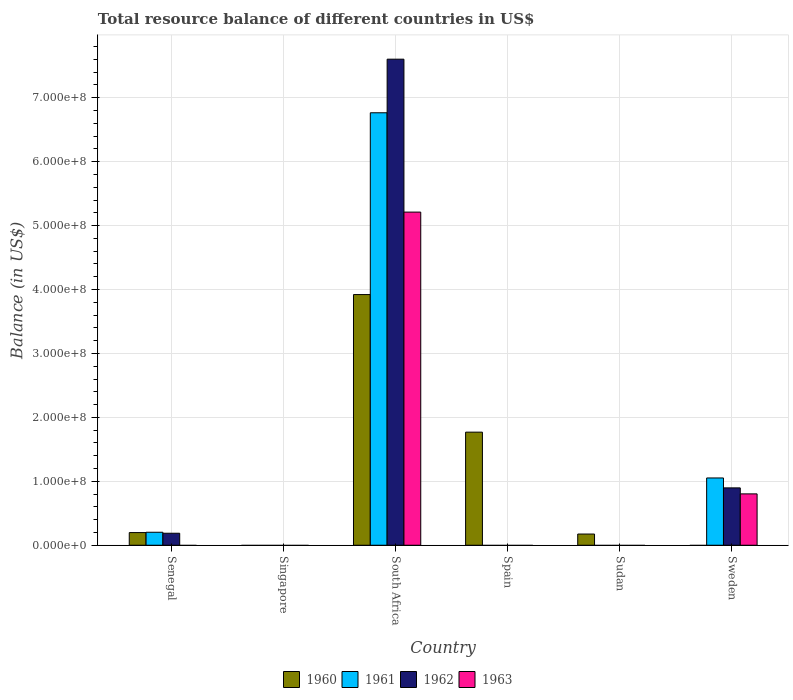Are the number of bars on each tick of the X-axis equal?
Provide a succinct answer. No. How many bars are there on the 3rd tick from the left?
Ensure brevity in your answer.  4. How many bars are there on the 5th tick from the right?
Your response must be concise. 0. What is the label of the 5th group of bars from the left?
Keep it short and to the point. Sudan. What is the total resource balance in 1960 in Spain?
Make the answer very short. 1.77e+08. Across all countries, what is the maximum total resource balance in 1963?
Make the answer very short. 5.21e+08. In which country was the total resource balance in 1963 maximum?
Provide a succinct answer. South Africa. What is the total total resource balance in 1960 in the graph?
Provide a succinct answer. 6.06e+08. What is the difference between the total resource balance in 1962 in Senegal and that in South Africa?
Your response must be concise. -7.42e+08. What is the difference between the total resource balance in 1962 in Sweden and the total resource balance in 1963 in Spain?
Offer a very short reply. 8.97e+07. What is the average total resource balance in 1963 per country?
Offer a terse response. 1.00e+08. What is the difference between the total resource balance of/in 1961 and total resource balance of/in 1963 in South Africa?
Offer a very short reply. 1.55e+08. What is the ratio of the total resource balance in 1960 in Senegal to that in Spain?
Your answer should be compact. 0.11. Is the total resource balance in 1960 in Senegal less than that in Spain?
Provide a succinct answer. Yes. What is the difference between the highest and the second highest total resource balance in 1960?
Keep it short and to the point. -3.72e+08. What is the difference between the highest and the lowest total resource balance in 1963?
Offer a terse response. 5.21e+08. In how many countries, is the total resource balance in 1962 greater than the average total resource balance in 1962 taken over all countries?
Offer a terse response. 1. Are all the bars in the graph horizontal?
Your response must be concise. No. What is the difference between two consecutive major ticks on the Y-axis?
Ensure brevity in your answer.  1.00e+08. Does the graph contain any zero values?
Keep it short and to the point. Yes. Does the graph contain grids?
Your answer should be compact. Yes. How many legend labels are there?
Your response must be concise. 4. What is the title of the graph?
Make the answer very short. Total resource balance of different countries in US$. Does "1974" appear as one of the legend labels in the graph?
Offer a very short reply. No. What is the label or title of the X-axis?
Offer a terse response. Country. What is the label or title of the Y-axis?
Provide a short and direct response. Balance (in US$). What is the Balance (in US$) of 1960 in Senegal?
Keep it short and to the point. 1.98e+07. What is the Balance (in US$) of 1961 in Senegal?
Your response must be concise. 2.03e+07. What is the Balance (in US$) of 1962 in Senegal?
Provide a short and direct response. 1.88e+07. What is the Balance (in US$) in 1963 in Senegal?
Your answer should be very brief. 0. What is the Balance (in US$) of 1962 in Singapore?
Your answer should be very brief. 0. What is the Balance (in US$) of 1960 in South Africa?
Your response must be concise. 3.92e+08. What is the Balance (in US$) in 1961 in South Africa?
Give a very brief answer. 6.77e+08. What is the Balance (in US$) in 1962 in South Africa?
Provide a succinct answer. 7.60e+08. What is the Balance (in US$) of 1963 in South Africa?
Ensure brevity in your answer.  5.21e+08. What is the Balance (in US$) in 1960 in Spain?
Offer a very short reply. 1.77e+08. What is the Balance (in US$) in 1963 in Spain?
Provide a short and direct response. 0. What is the Balance (in US$) in 1960 in Sudan?
Provide a succinct answer. 1.75e+07. What is the Balance (in US$) in 1961 in Sudan?
Your answer should be very brief. 0. What is the Balance (in US$) in 1963 in Sudan?
Provide a succinct answer. 0. What is the Balance (in US$) in 1960 in Sweden?
Make the answer very short. 0. What is the Balance (in US$) of 1961 in Sweden?
Offer a very short reply. 1.05e+08. What is the Balance (in US$) in 1962 in Sweden?
Make the answer very short. 8.97e+07. What is the Balance (in US$) of 1963 in Sweden?
Your answer should be very brief. 8.03e+07. Across all countries, what is the maximum Balance (in US$) in 1960?
Your answer should be compact. 3.92e+08. Across all countries, what is the maximum Balance (in US$) in 1961?
Provide a succinct answer. 6.77e+08. Across all countries, what is the maximum Balance (in US$) of 1962?
Your answer should be very brief. 7.60e+08. Across all countries, what is the maximum Balance (in US$) of 1963?
Keep it short and to the point. 5.21e+08. Across all countries, what is the minimum Balance (in US$) in 1960?
Make the answer very short. 0. Across all countries, what is the minimum Balance (in US$) in 1961?
Offer a terse response. 0. What is the total Balance (in US$) of 1960 in the graph?
Provide a succinct answer. 6.06e+08. What is the total Balance (in US$) of 1961 in the graph?
Provide a succinct answer. 8.02e+08. What is the total Balance (in US$) in 1962 in the graph?
Ensure brevity in your answer.  8.69e+08. What is the total Balance (in US$) in 1963 in the graph?
Make the answer very short. 6.01e+08. What is the difference between the Balance (in US$) of 1960 in Senegal and that in South Africa?
Offer a terse response. -3.72e+08. What is the difference between the Balance (in US$) of 1961 in Senegal and that in South Africa?
Your answer should be compact. -6.56e+08. What is the difference between the Balance (in US$) in 1962 in Senegal and that in South Africa?
Your answer should be very brief. -7.42e+08. What is the difference between the Balance (in US$) of 1960 in Senegal and that in Spain?
Your response must be concise. -1.57e+08. What is the difference between the Balance (in US$) in 1960 in Senegal and that in Sudan?
Provide a succinct answer. 2.27e+06. What is the difference between the Balance (in US$) in 1961 in Senegal and that in Sweden?
Make the answer very short. -8.49e+07. What is the difference between the Balance (in US$) in 1962 in Senegal and that in Sweden?
Provide a short and direct response. -7.10e+07. What is the difference between the Balance (in US$) of 1960 in South Africa and that in Spain?
Provide a succinct answer. 2.15e+08. What is the difference between the Balance (in US$) in 1960 in South Africa and that in Sudan?
Ensure brevity in your answer.  3.75e+08. What is the difference between the Balance (in US$) of 1961 in South Africa and that in Sweden?
Your answer should be compact. 5.71e+08. What is the difference between the Balance (in US$) of 1962 in South Africa and that in Sweden?
Your answer should be compact. 6.71e+08. What is the difference between the Balance (in US$) of 1963 in South Africa and that in Sweden?
Keep it short and to the point. 4.41e+08. What is the difference between the Balance (in US$) in 1960 in Spain and that in Sudan?
Ensure brevity in your answer.  1.59e+08. What is the difference between the Balance (in US$) of 1960 in Senegal and the Balance (in US$) of 1961 in South Africa?
Ensure brevity in your answer.  -6.57e+08. What is the difference between the Balance (in US$) in 1960 in Senegal and the Balance (in US$) in 1962 in South Africa?
Give a very brief answer. -7.41e+08. What is the difference between the Balance (in US$) of 1960 in Senegal and the Balance (in US$) of 1963 in South Africa?
Offer a very short reply. -5.01e+08. What is the difference between the Balance (in US$) of 1961 in Senegal and the Balance (in US$) of 1962 in South Africa?
Offer a terse response. -7.40e+08. What is the difference between the Balance (in US$) of 1961 in Senegal and the Balance (in US$) of 1963 in South Africa?
Give a very brief answer. -5.01e+08. What is the difference between the Balance (in US$) in 1962 in Senegal and the Balance (in US$) in 1963 in South Africa?
Give a very brief answer. -5.02e+08. What is the difference between the Balance (in US$) in 1960 in Senegal and the Balance (in US$) in 1961 in Sweden?
Provide a short and direct response. -8.54e+07. What is the difference between the Balance (in US$) in 1960 in Senegal and the Balance (in US$) in 1962 in Sweden?
Keep it short and to the point. -6.99e+07. What is the difference between the Balance (in US$) in 1960 in Senegal and the Balance (in US$) in 1963 in Sweden?
Offer a very short reply. -6.05e+07. What is the difference between the Balance (in US$) of 1961 in Senegal and the Balance (in US$) of 1962 in Sweden?
Make the answer very short. -6.94e+07. What is the difference between the Balance (in US$) in 1961 in Senegal and the Balance (in US$) in 1963 in Sweden?
Offer a terse response. -6.00e+07. What is the difference between the Balance (in US$) in 1962 in Senegal and the Balance (in US$) in 1963 in Sweden?
Ensure brevity in your answer.  -6.16e+07. What is the difference between the Balance (in US$) in 1960 in South Africa and the Balance (in US$) in 1961 in Sweden?
Your response must be concise. 2.87e+08. What is the difference between the Balance (in US$) of 1960 in South Africa and the Balance (in US$) of 1962 in Sweden?
Offer a very short reply. 3.02e+08. What is the difference between the Balance (in US$) of 1960 in South Africa and the Balance (in US$) of 1963 in Sweden?
Your answer should be very brief. 3.12e+08. What is the difference between the Balance (in US$) in 1961 in South Africa and the Balance (in US$) in 1962 in Sweden?
Offer a terse response. 5.87e+08. What is the difference between the Balance (in US$) in 1961 in South Africa and the Balance (in US$) in 1963 in Sweden?
Keep it short and to the point. 5.96e+08. What is the difference between the Balance (in US$) of 1962 in South Africa and the Balance (in US$) of 1963 in Sweden?
Your answer should be compact. 6.80e+08. What is the difference between the Balance (in US$) of 1960 in Spain and the Balance (in US$) of 1961 in Sweden?
Ensure brevity in your answer.  7.17e+07. What is the difference between the Balance (in US$) of 1960 in Spain and the Balance (in US$) of 1962 in Sweden?
Provide a succinct answer. 8.72e+07. What is the difference between the Balance (in US$) in 1960 in Spain and the Balance (in US$) in 1963 in Sweden?
Make the answer very short. 9.66e+07. What is the difference between the Balance (in US$) in 1960 in Sudan and the Balance (in US$) in 1961 in Sweden?
Offer a very short reply. -8.77e+07. What is the difference between the Balance (in US$) of 1960 in Sudan and the Balance (in US$) of 1962 in Sweden?
Your answer should be compact. -7.22e+07. What is the difference between the Balance (in US$) of 1960 in Sudan and the Balance (in US$) of 1963 in Sweden?
Offer a terse response. -6.28e+07. What is the average Balance (in US$) in 1960 per country?
Offer a very short reply. 1.01e+08. What is the average Balance (in US$) in 1961 per country?
Your answer should be very brief. 1.34e+08. What is the average Balance (in US$) in 1962 per country?
Give a very brief answer. 1.45e+08. What is the average Balance (in US$) in 1963 per country?
Offer a very short reply. 1.00e+08. What is the difference between the Balance (in US$) of 1960 and Balance (in US$) of 1961 in Senegal?
Give a very brief answer. -5.23e+05. What is the difference between the Balance (in US$) in 1960 and Balance (in US$) in 1962 in Senegal?
Ensure brevity in your answer.  1.03e+06. What is the difference between the Balance (in US$) of 1961 and Balance (in US$) of 1962 in Senegal?
Provide a succinct answer. 1.55e+06. What is the difference between the Balance (in US$) in 1960 and Balance (in US$) in 1961 in South Africa?
Give a very brief answer. -2.84e+08. What is the difference between the Balance (in US$) in 1960 and Balance (in US$) in 1962 in South Africa?
Provide a short and direct response. -3.68e+08. What is the difference between the Balance (in US$) of 1960 and Balance (in US$) of 1963 in South Africa?
Keep it short and to the point. -1.29e+08. What is the difference between the Balance (in US$) in 1961 and Balance (in US$) in 1962 in South Africa?
Offer a terse response. -8.38e+07. What is the difference between the Balance (in US$) of 1961 and Balance (in US$) of 1963 in South Africa?
Keep it short and to the point. 1.55e+08. What is the difference between the Balance (in US$) of 1962 and Balance (in US$) of 1963 in South Africa?
Your answer should be compact. 2.39e+08. What is the difference between the Balance (in US$) of 1961 and Balance (in US$) of 1962 in Sweden?
Provide a short and direct response. 1.55e+07. What is the difference between the Balance (in US$) of 1961 and Balance (in US$) of 1963 in Sweden?
Make the answer very short. 2.49e+07. What is the difference between the Balance (in US$) of 1962 and Balance (in US$) of 1963 in Sweden?
Your response must be concise. 9.40e+06. What is the ratio of the Balance (in US$) in 1960 in Senegal to that in South Africa?
Ensure brevity in your answer.  0.05. What is the ratio of the Balance (in US$) of 1961 in Senegal to that in South Africa?
Your answer should be compact. 0.03. What is the ratio of the Balance (in US$) in 1962 in Senegal to that in South Africa?
Your response must be concise. 0.02. What is the ratio of the Balance (in US$) of 1960 in Senegal to that in Spain?
Keep it short and to the point. 0.11. What is the ratio of the Balance (in US$) of 1960 in Senegal to that in Sudan?
Offer a very short reply. 1.13. What is the ratio of the Balance (in US$) of 1961 in Senegal to that in Sweden?
Provide a short and direct response. 0.19. What is the ratio of the Balance (in US$) of 1962 in Senegal to that in Sweden?
Offer a very short reply. 0.21. What is the ratio of the Balance (in US$) in 1960 in South Africa to that in Spain?
Your answer should be compact. 2.22. What is the ratio of the Balance (in US$) of 1960 in South Africa to that in Sudan?
Your answer should be very brief. 22.38. What is the ratio of the Balance (in US$) of 1961 in South Africa to that in Sweden?
Your response must be concise. 6.43. What is the ratio of the Balance (in US$) of 1962 in South Africa to that in Sweden?
Ensure brevity in your answer.  8.47. What is the ratio of the Balance (in US$) of 1963 in South Africa to that in Sweden?
Provide a succinct answer. 6.49. What is the ratio of the Balance (in US$) in 1960 in Spain to that in Sudan?
Provide a short and direct response. 10.1. What is the difference between the highest and the second highest Balance (in US$) of 1960?
Offer a very short reply. 2.15e+08. What is the difference between the highest and the second highest Balance (in US$) of 1961?
Give a very brief answer. 5.71e+08. What is the difference between the highest and the second highest Balance (in US$) in 1962?
Make the answer very short. 6.71e+08. What is the difference between the highest and the lowest Balance (in US$) of 1960?
Give a very brief answer. 3.92e+08. What is the difference between the highest and the lowest Balance (in US$) of 1961?
Give a very brief answer. 6.77e+08. What is the difference between the highest and the lowest Balance (in US$) in 1962?
Give a very brief answer. 7.60e+08. What is the difference between the highest and the lowest Balance (in US$) in 1963?
Offer a terse response. 5.21e+08. 